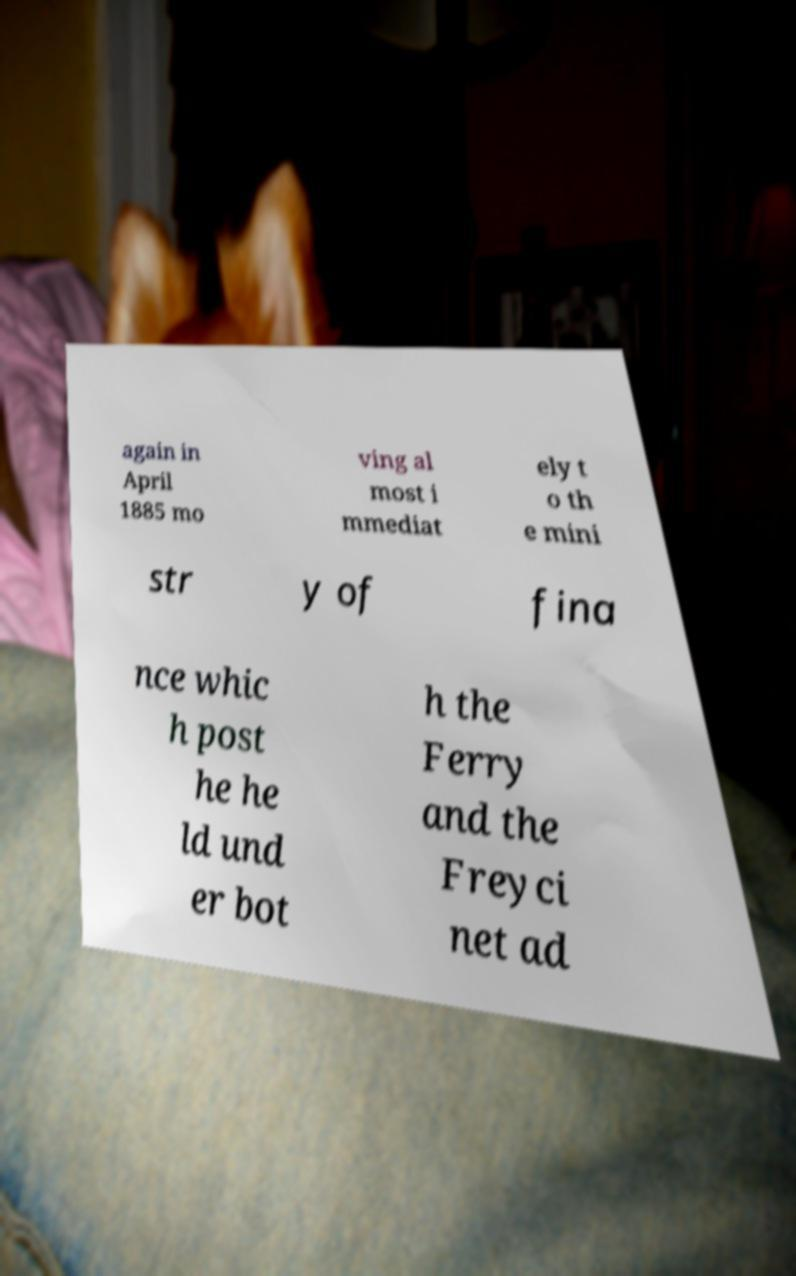Could you assist in decoding the text presented in this image and type it out clearly? again in April 1885 mo ving al most i mmediat ely t o th e mini str y of fina nce whic h post he he ld und er bot h the Ferry and the Freyci net ad 